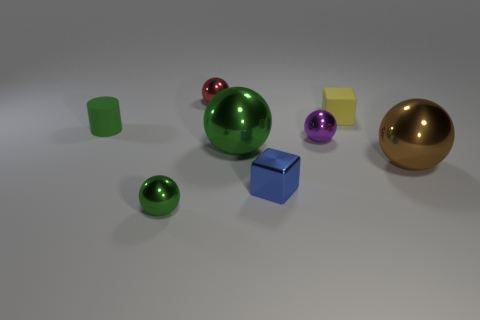What number of objects are large green rubber spheres or tiny matte things?
Offer a very short reply. 2. Is the number of red metal spheres in front of the purple metal ball less than the number of tiny purple balls?
Provide a succinct answer. Yes. Are there more big brown balls that are right of the blue metal object than matte cylinders that are in front of the tiny green rubber object?
Your response must be concise. Yes. Is there anything else of the same color as the rubber cube?
Offer a very short reply. No. There is a small cube right of the purple shiny sphere; what material is it?
Keep it short and to the point. Rubber. Do the blue shiny cube and the cylinder have the same size?
Give a very brief answer. Yes. How many other things are there of the same size as the brown thing?
Your response must be concise. 1. What shape is the green thing that is in front of the large ball to the left of the small rubber object right of the tiny blue metallic cube?
Your answer should be very brief. Sphere. What number of things are things that are in front of the small purple object or balls that are behind the yellow object?
Provide a short and direct response. 5. What size is the ball that is in front of the shiny ball that is on the right side of the purple object?
Provide a short and direct response. Small. 